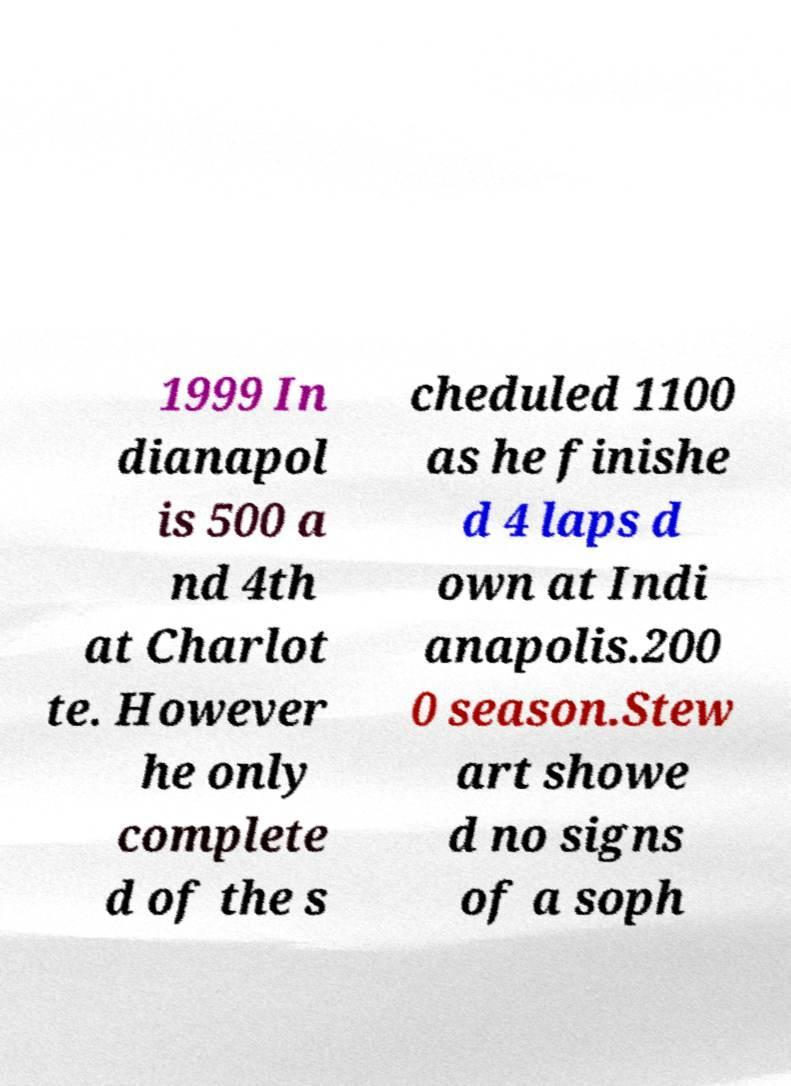I need the written content from this picture converted into text. Can you do that? 1999 In dianapol is 500 a nd 4th at Charlot te. However he only complete d of the s cheduled 1100 as he finishe d 4 laps d own at Indi anapolis.200 0 season.Stew art showe d no signs of a soph 